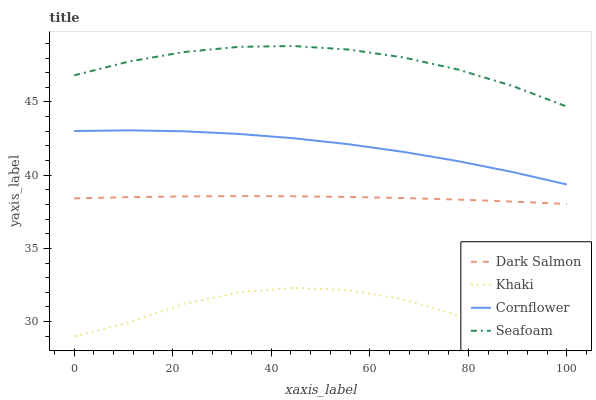Does Khaki have the minimum area under the curve?
Answer yes or no. Yes. Does Seafoam have the maximum area under the curve?
Answer yes or no. Yes. Does Dark Salmon have the minimum area under the curve?
Answer yes or no. No. Does Dark Salmon have the maximum area under the curve?
Answer yes or no. No. Is Dark Salmon the smoothest?
Answer yes or no. Yes. Is Khaki the roughest?
Answer yes or no. Yes. Is Khaki the smoothest?
Answer yes or no. No. Is Dark Salmon the roughest?
Answer yes or no. No. Does Khaki have the lowest value?
Answer yes or no. Yes. Does Dark Salmon have the lowest value?
Answer yes or no. No. Does Seafoam have the highest value?
Answer yes or no. Yes. Does Dark Salmon have the highest value?
Answer yes or no. No. Is Khaki less than Seafoam?
Answer yes or no. Yes. Is Dark Salmon greater than Khaki?
Answer yes or no. Yes. Does Khaki intersect Seafoam?
Answer yes or no. No. 